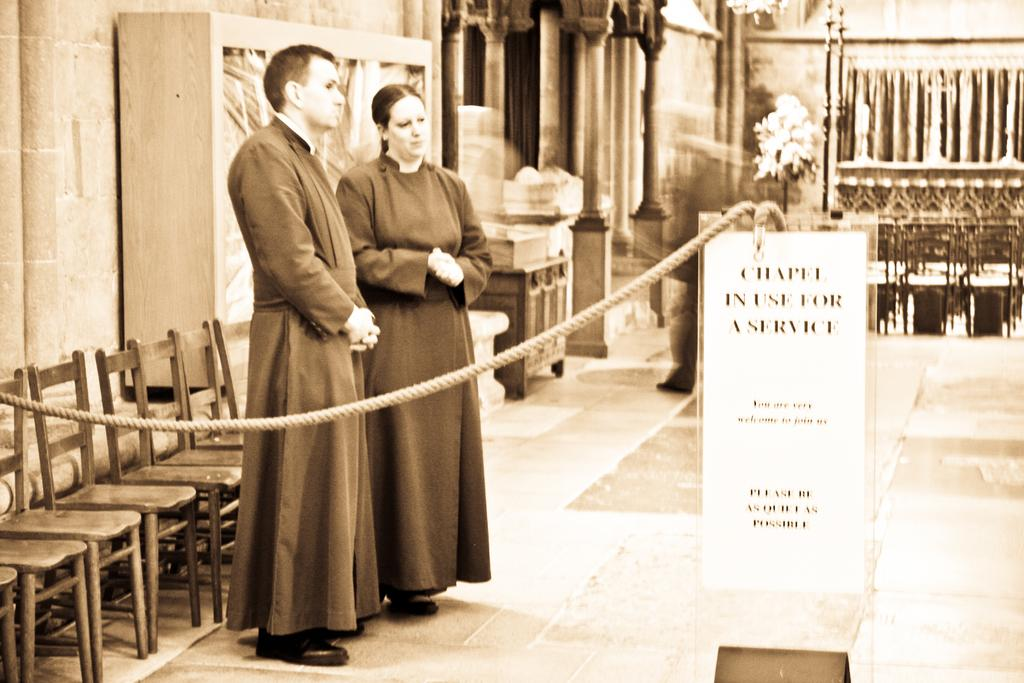How many people are standing in the image? There are two persons standing in the image. What is in front of the persons? There is a rope and a banner in front of the persons. What is behind the persons? There are chairs behind the persons. What can be seen in the background of the image? There are pillars and a cupboard in the background. What historical event is being taught in the image? There is no indication of a historical event or teaching in the image. What type of paste is being used to stick the banner to the rope? There is no information about any paste being used in the image. 